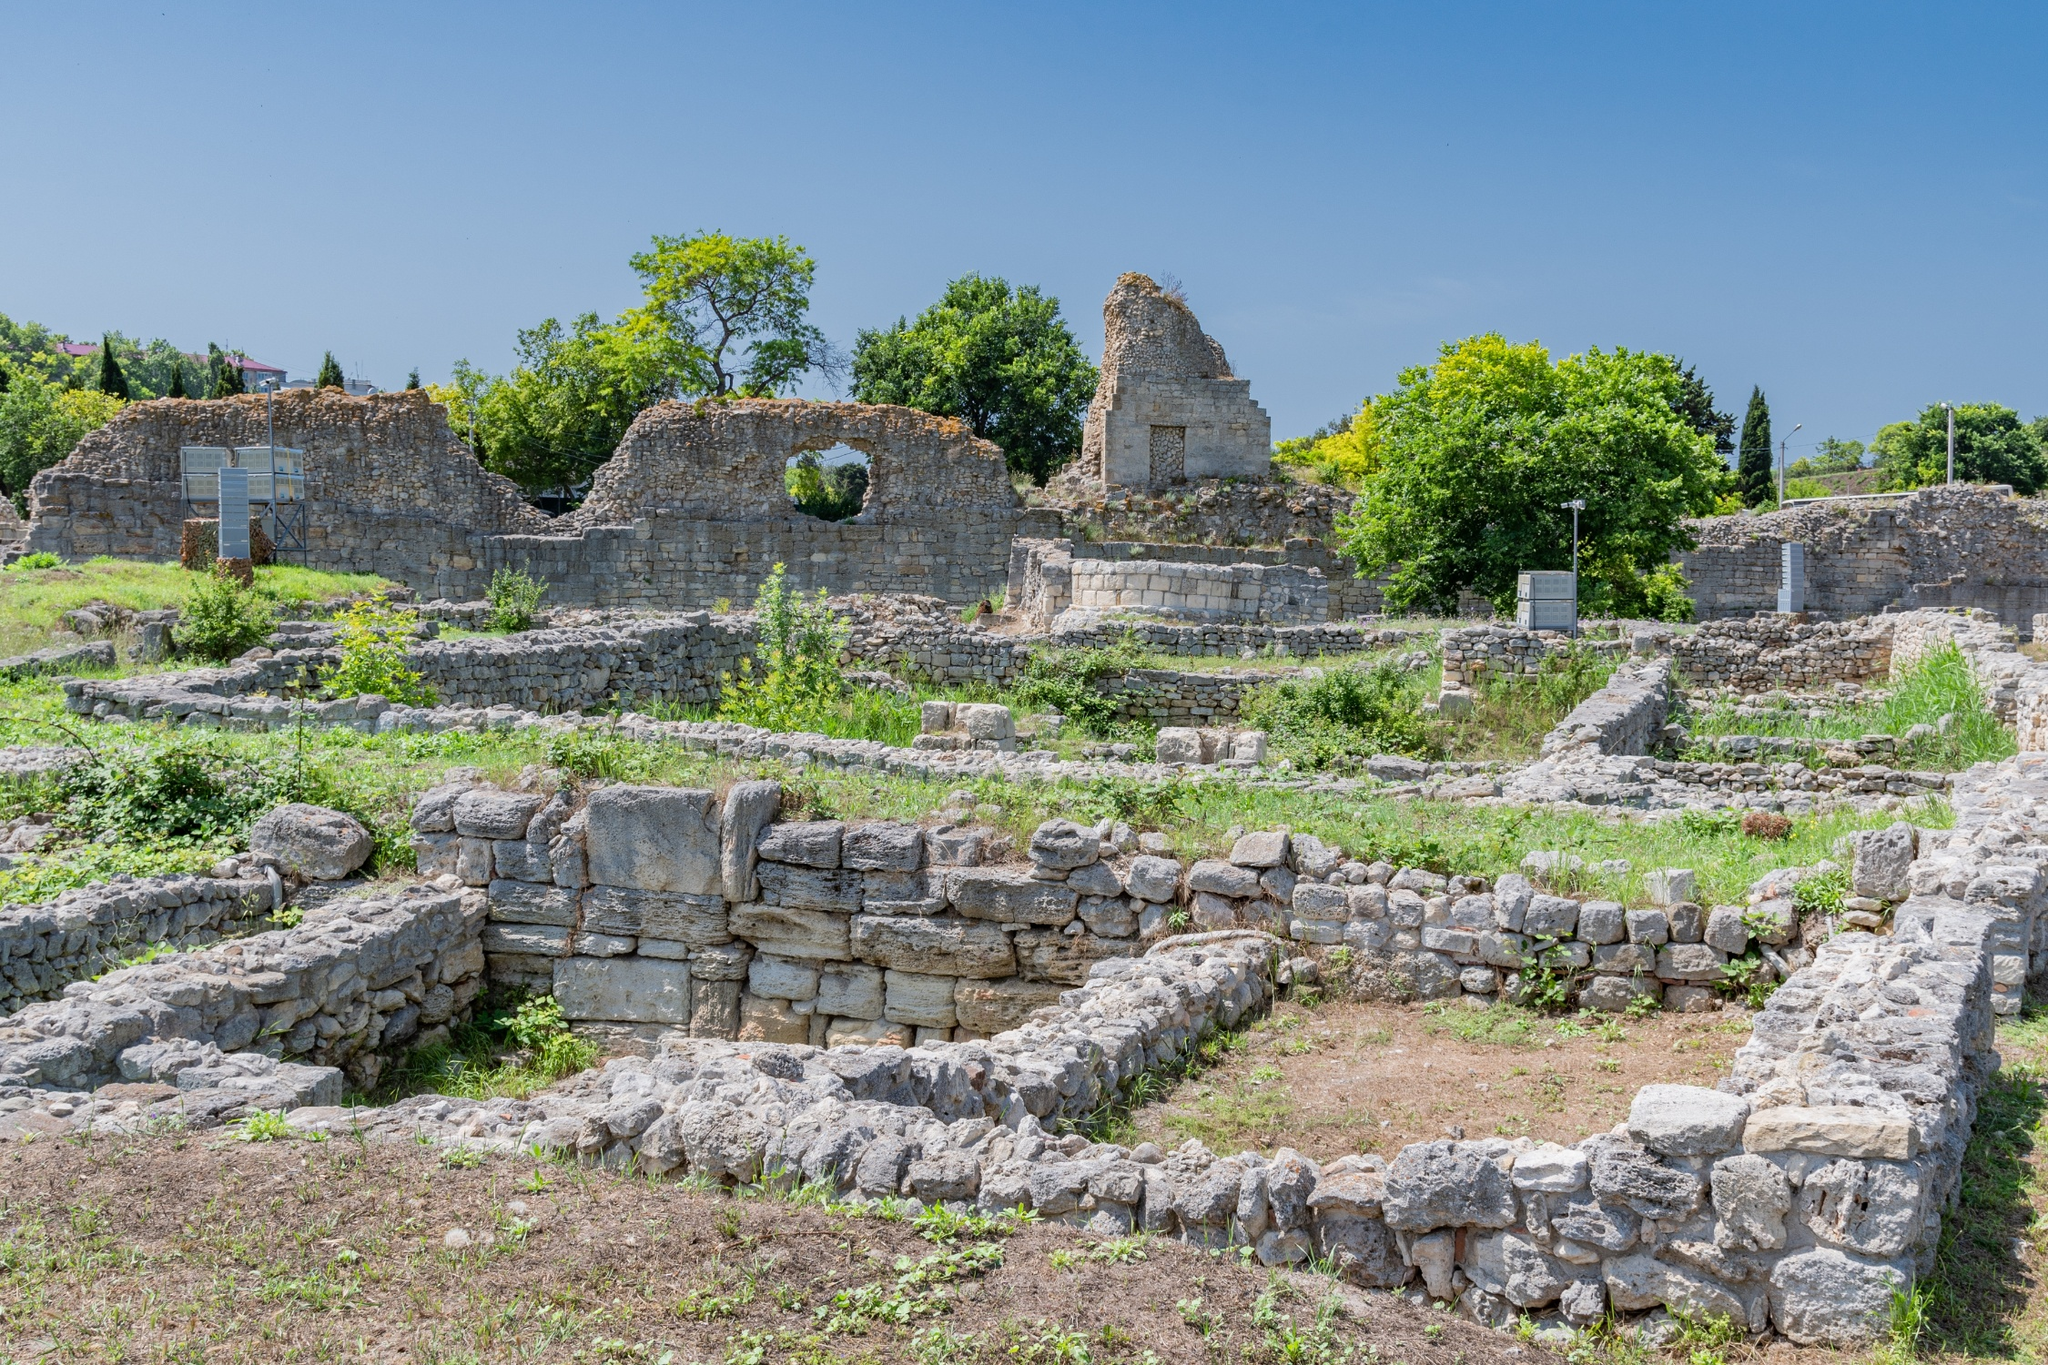What fantastical creatures might once have roamed these ruins? In an imagined era long before our understanding, these ruins might have been the domain of majestic, mythical creatures. Envision colossal stone guardians sculpted into life, patrolling the city by night, their eyes glowing with an ancient, mystical energy. Perhaps dragons with scales shimmering like precious gems once soared above, casting shadows over the bustling populace below. There could have been elusive spirits of the forest, entities of immense wisdom, communing with the city dwellers, offering protection and guidance. Ethereal beings with wings like translucent silks might have graced the temples, their presence a bridge between the divine and the mortal realms. The ruins, in their prime, could have been a realm where myth and reality intertwined seamlessly, creating a tapestry of magic and wonder defining the city's spirit. 